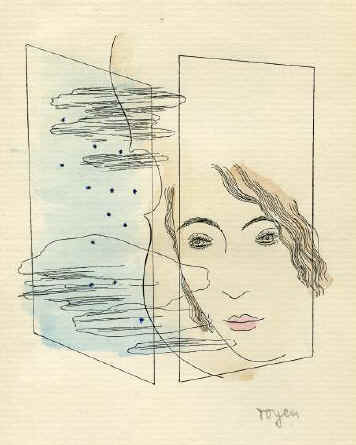Could you explain the significance of the blue elements in the background? The blue elements in the artwork's background could represent tranquility and depth, often associated with the color blue. In the context of the surrealistic style, these forms might symbolize the subconscious ocean of the mind, where thoughts and emotions swirl in an unstructured form. Their interaction with the precise line-drawn face could be portraying the complex interplay between calm introspection and the swirling chaos of human emotion. 